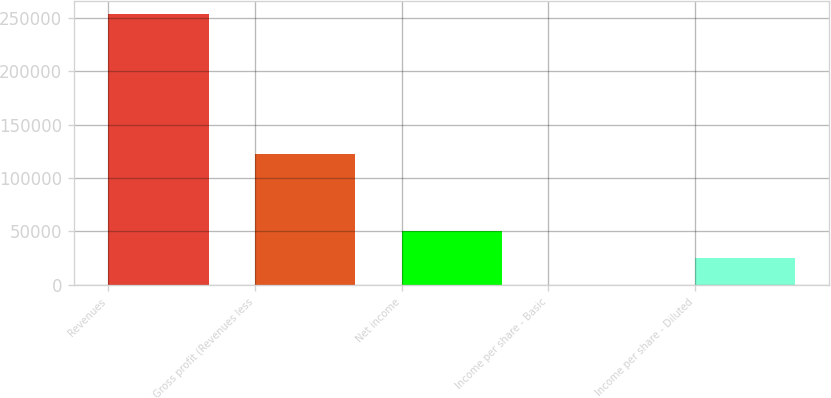Convert chart to OTSL. <chart><loc_0><loc_0><loc_500><loc_500><bar_chart><fcel>Revenues<fcel>Gross profit (Revenues less<fcel>Net income<fcel>Income per share - Basic<fcel>Income per share - Diluted<nl><fcel>253041<fcel>122066<fcel>50608.3<fcel>0.12<fcel>25304.2<nl></chart> 